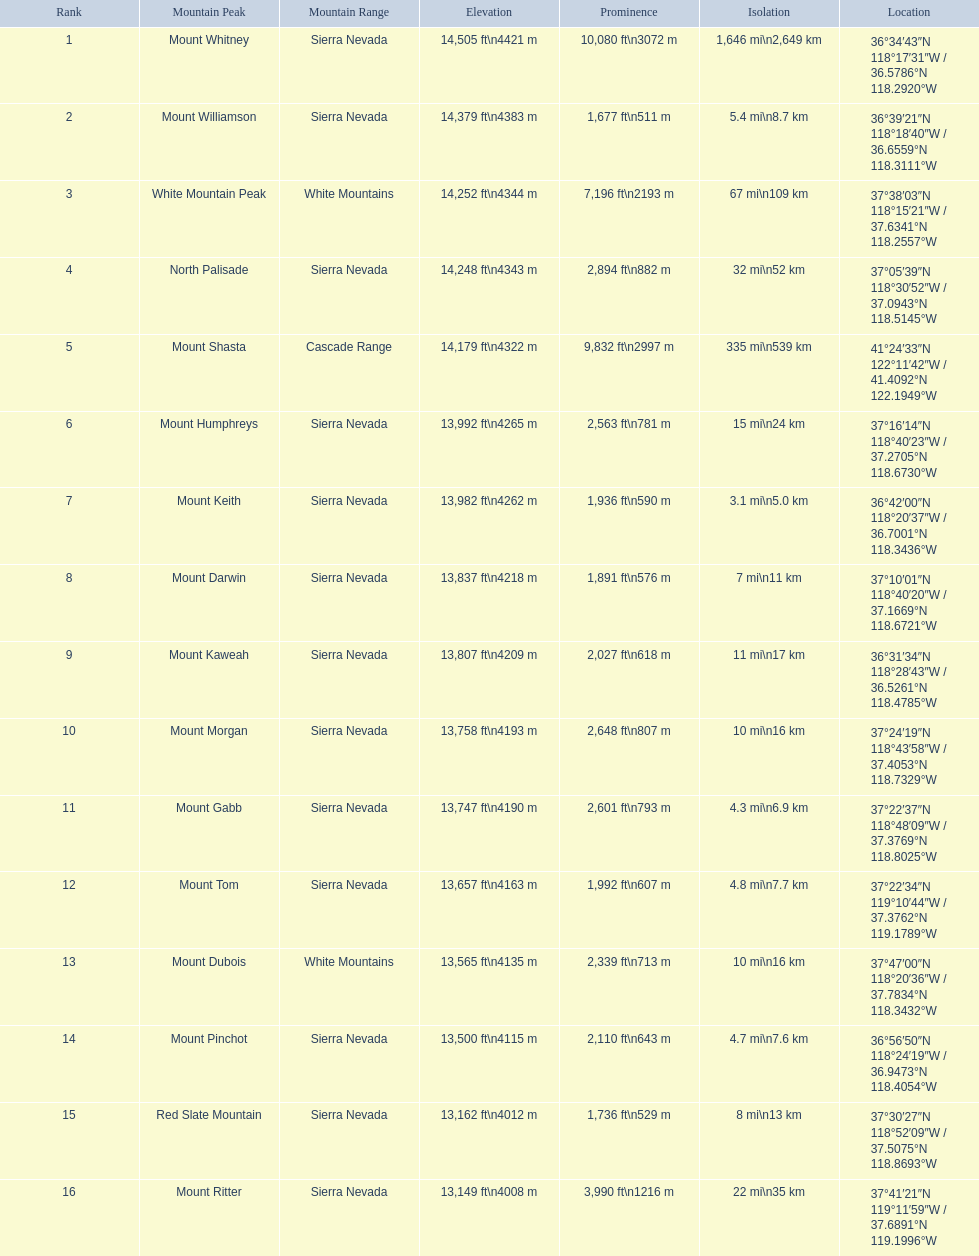What are the heights of the californian mountain peaks? 14,505 ft\n4421 m, 14,379 ft\n4383 m, 14,252 ft\n4344 m, 14,248 ft\n4343 m, 14,179 ft\n4322 m, 13,992 ft\n4265 m, 13,982 ft\n4262 m, 13,837 ft\n4218 m, 13,807 ft\n4209 m, 13,758 ft\n4193 m, 13,747 ft\n4190 m, 13,657 ft\n4163 m, 13,565 ft\n4135 m, 13,500 ft\n4115 m, 13,162 ft\n4012 m, 13,149 ft\n4008 m. What elevation is 13,149 ft or less? 13,149 ft\n4008 m. What mountain peak is at this elevation? Mount Ritter. 